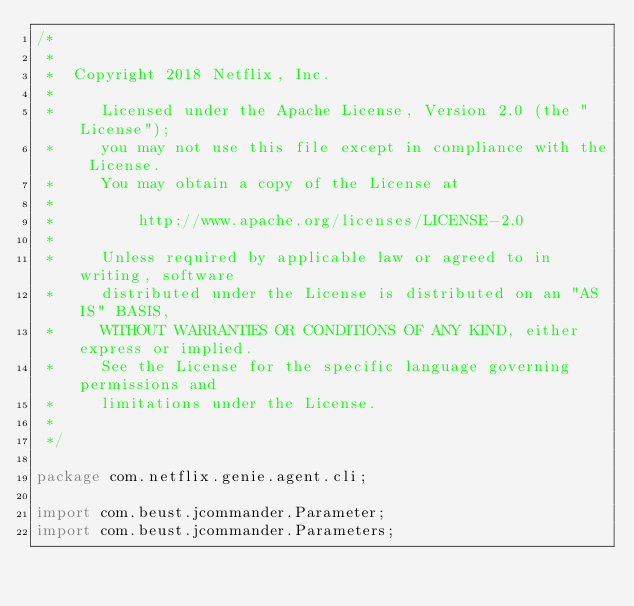Convert code to text. <code><loc_0><loc_0><loc_500><loc_500><_Java_>/*
 *
 *  Copyright 2018 Netflix, Inc.
 *
 *     Licensed under the Apache License, Version 2.0 (the "License");
 *     you may not use this file except in compliance with the License.
 *     You may obtain a copy of the License at
 *
 *         http://www.apache.org/licenses/LICENSE-2.0
 *
 *     Unless required by applicable law or agreed to in writing, software
 *     distributed under the License is distributed on an "AS IS" BASIS,
 *     WITHOUT WARRANTIES OR CONDITIONS OF ANY KIND, either express or implied.
 *     See the License for the specific language governing permissions and
 *     limitations under the License.
 *
 */

package com.netflix.genie.agent.cli;

import com.beust.jcommander.Parameter;
import com.beust.jcommander.Parameters;</code> 